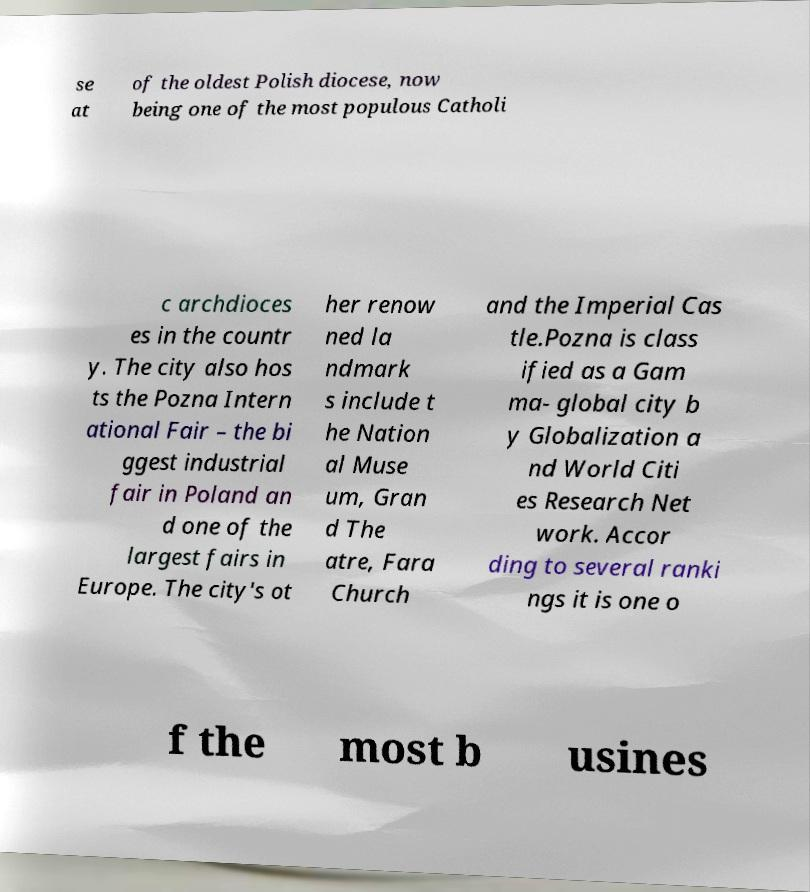What messages or text are displayed in this image? I need them in a readable, typed format. se at of the oldest Polish diocese, now being one of the most populous Catholi c archdioces es in the countr y. The city also hos ts the Pozna Intern ational Fair – the bi ggest industrial fair in Poland an d one of the largest fairs in Europe. The city's ot her renow ned la ndmark s include t he Nation al Muse um, Gran d The atre, Fara Church and the Imperial Cas tle.Pozna is class ified as a Gam ma- global city b y Globalization a nd World Citi es Research Net work. Accor ding to several ranki ngs it is one o f the most b usines 